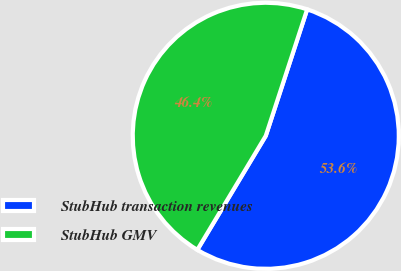Convert chart to OTSL. <chart><loc_0><loc_0><loc_500><loc_500><pie_chart><fcel>StubHub transaction revenues<fcel>StubHub GMV<nl><fcel>53.57%<fcel>46.43%<nl></chart> 